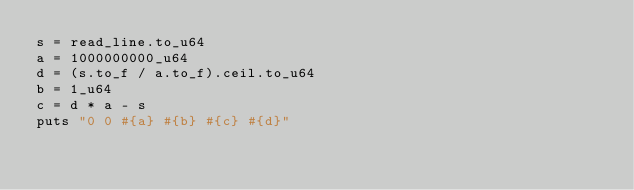<code> <loc_0><loc_0><loc_500><loc_500><_Crystal_>s = read_line.to_u64
a = 1000000000_u64
d = (s.to_f / a.to_f).ceil.to_u64
b = 1_u64
c = d * a - s
puts "0 0 #{a} #{b} #{c} #{d}"
</code> 